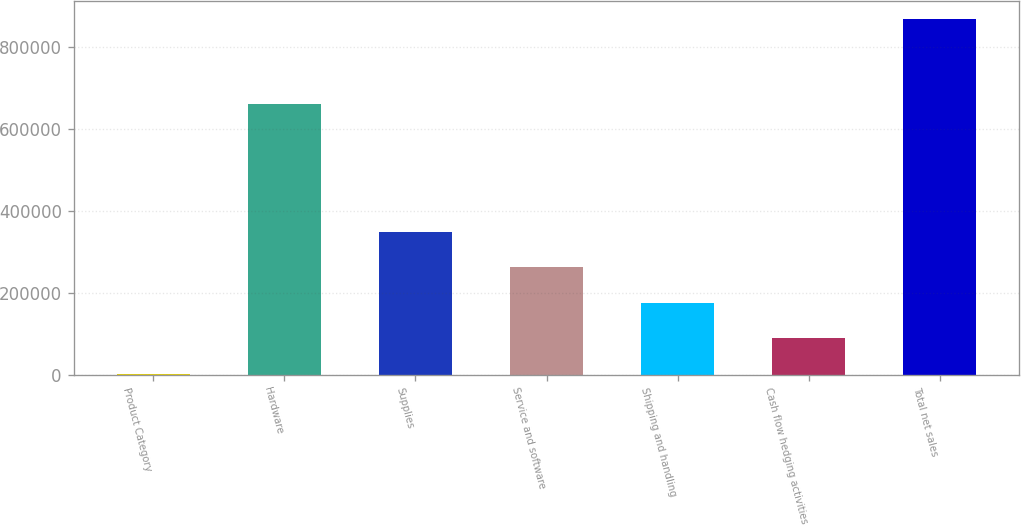<chart> <loc_0><loc_0><loc_500><loc_500><bar_chart><fcel>Product Category<fcel>Hardware<fcel>Supplies<fcel>Service and software<fcel>Shipping and handling<fcel>Cash flow hedging activities<fcel>Total net sales<nl><fcel>2007<fcel>660034<fcel>348516<fcel>261889<fcel>175261<fcel>88634.2<fcel>868279<nl></chart> 